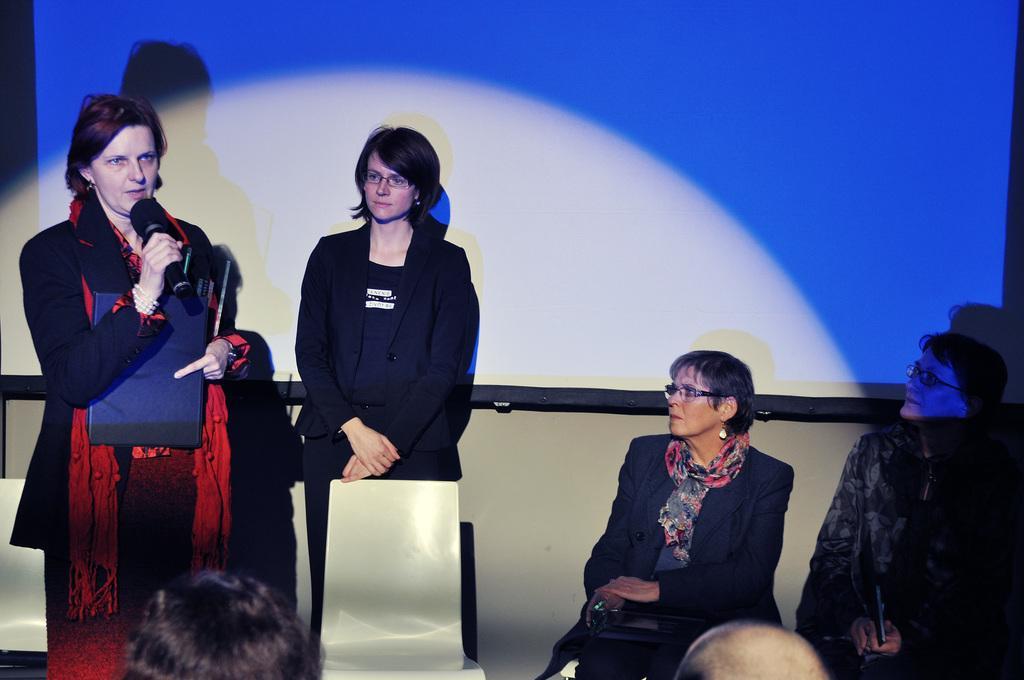How would you summarize this image in a sentence or two? In this image there is a woman holding a mike. She is standing. Beside her there is a chair. Behind there is a woman standing. There are two women sitting. Bottom of the image there are people. There is a screen. Background there is a wall. 